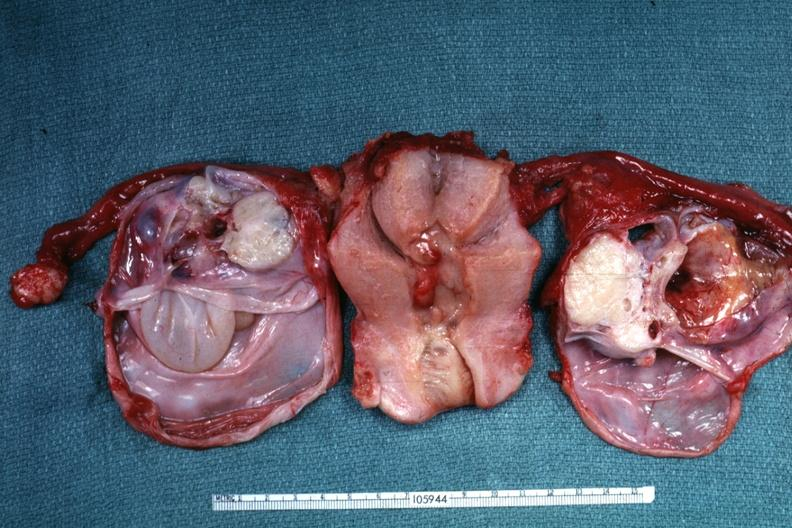what have been cut to show multiloculated nature of tumor masses?
Answer the question using a single word or phrase. Ovaries 